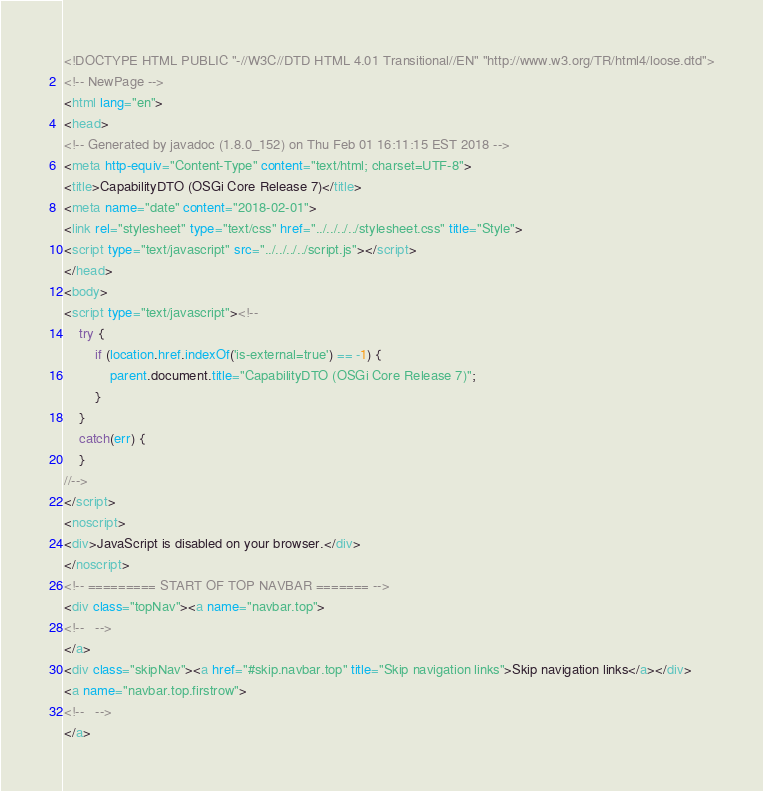<code> <loc_0><loc_0><loc_500><loc_500><_HTML_><!DOCTYPE HTML PUBLIC "-//W3C//DTD HTML 4.01 Transitional//EN" "http://www.w3.org/TR/html4/loose.dtd">
<!-- NewPage -->
<html lang="en">
<head>
<!-- Generated by javadoc (1.8.0_152) on Thu Feb 01 16:11:15 EST 2018 -->
<meta http-equiv="Content-Type" content="text/html; charset=UTF-8">
<title>CapabilityDTO (OSGi Core Release 7)</title>
<meta name="date" content="2018-02-01">
<link rel="stylesheet" type="text/css" href="../../../../stylesheet.css" title="Style">
<script type="text/javascript" src="../../../../script.js"></script>
</head>
<body>
<script type="text/javascript"><!--
    try {
        if (location.href.indexOf('is-external=true') == -1) {
            parent.document.title="CapabilityDTO (OSGi Core Release 7)";
        }
    }
    catch(err) {
    }
//-->
</script>
<noscript>
<div>JavaScript is disabled on your browser.</div>
</noscript>
<!-- ========= START OF TOP NAVBAR ======= -->
<div class="topNav"><a name="navbar.top">
<!--   -->
</a>
<div class="skipNav"><a href="#skip.navbar.top" title="Skip navigation links">Skip navigation links</a></div>
<a name="navbar.top.firstrow">
<!--   -->
</a></code> 